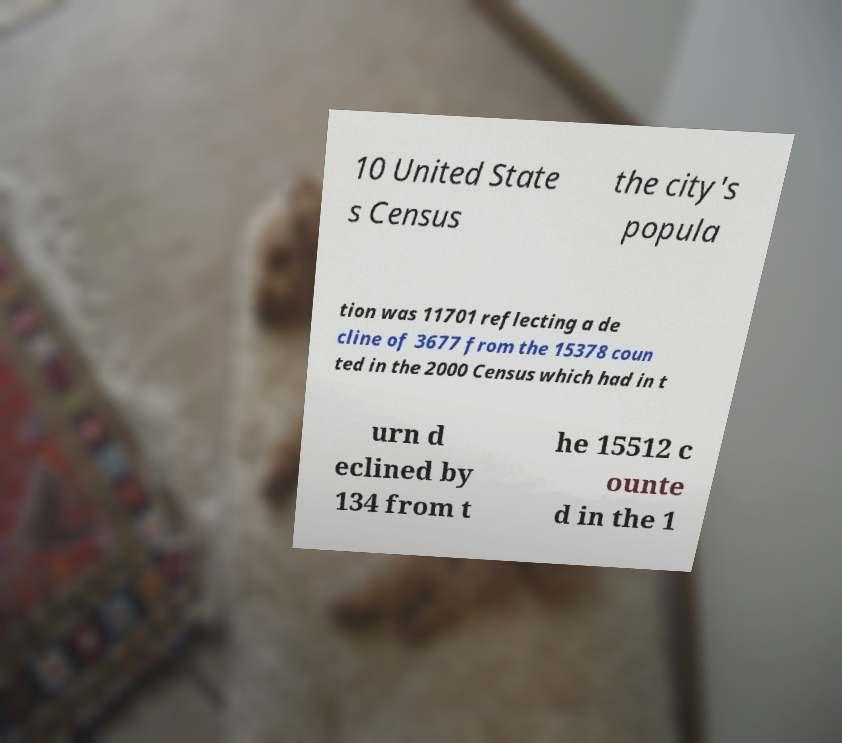Could you extract and type out the text from this image? 10 United State s Census the city's popula tion was 11701 reflecting a de cline of 3677 from the 15378 coun ted in the 2000 Census which had in t urn d eclined by 134 from t he 15512 c ounte d in the 1 